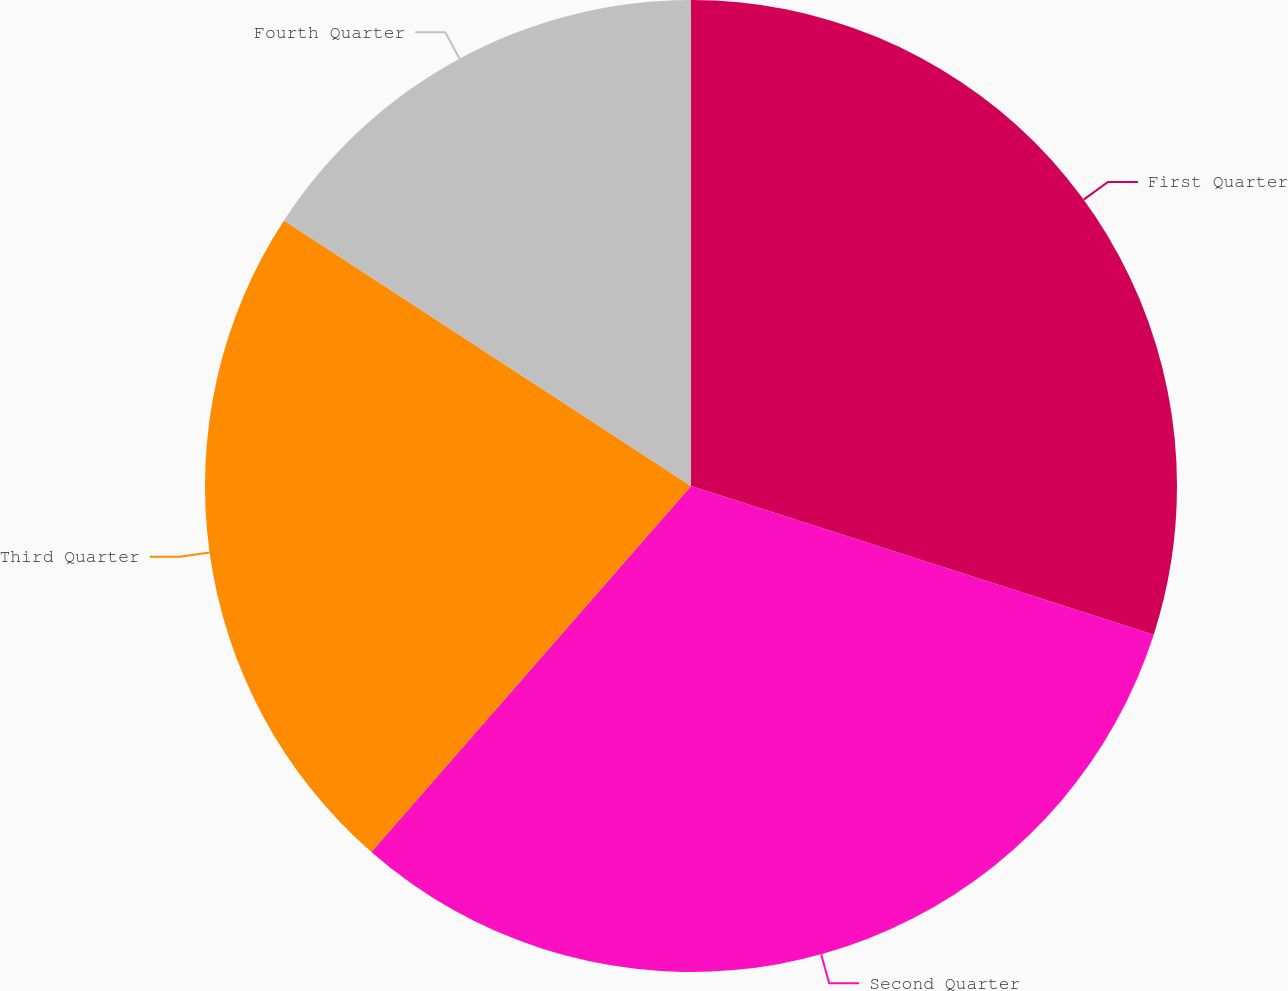<chart> <loc_0><loc_0><loc_500><loc_500><pie_chart><fcel>First Quarter<fcel>Second Quarter<fcel>Third Quarter<fcel>Fourth Quarter<nl><fcel>29.95%<fcel>31.48%<fcel>22.78%<fcel>15.8%<nl></chart> 